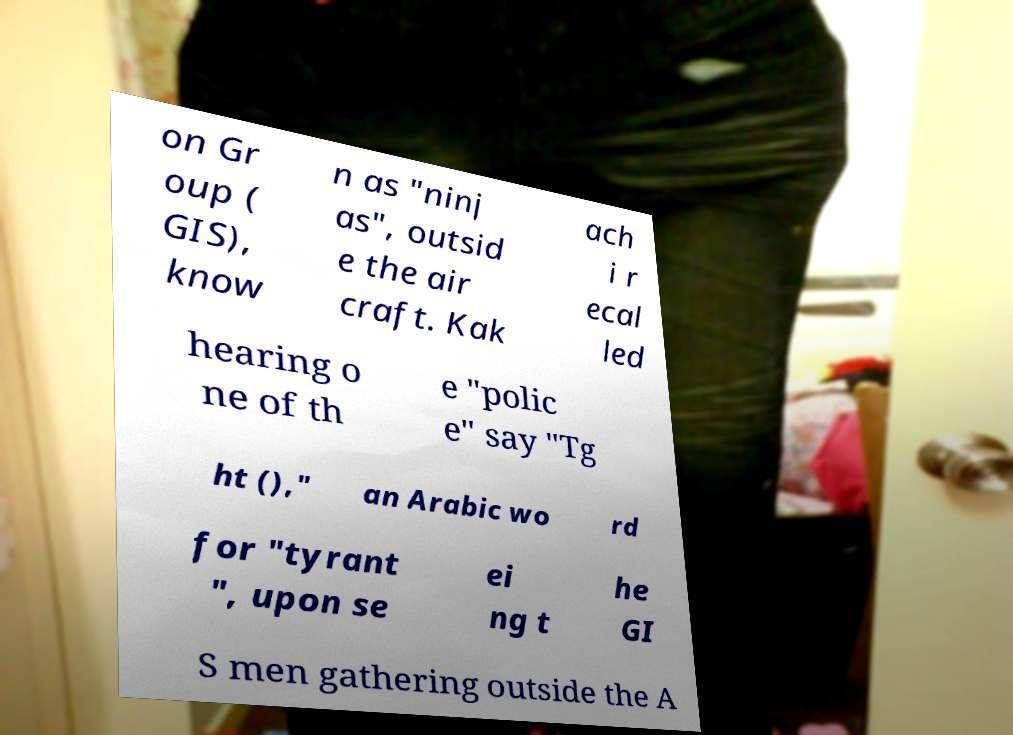Please read and relay the text visible in this image. What does it say? on Gr oup ( GIS), know n as "ninj as", outsid e the air craft. Kak ach i r ecal led hearing o ne of th e "polic e" say "Tg ht ()," an Arabic wo rd for "tyrant ", upon se ei ng t he GI S men gathering outside the A 